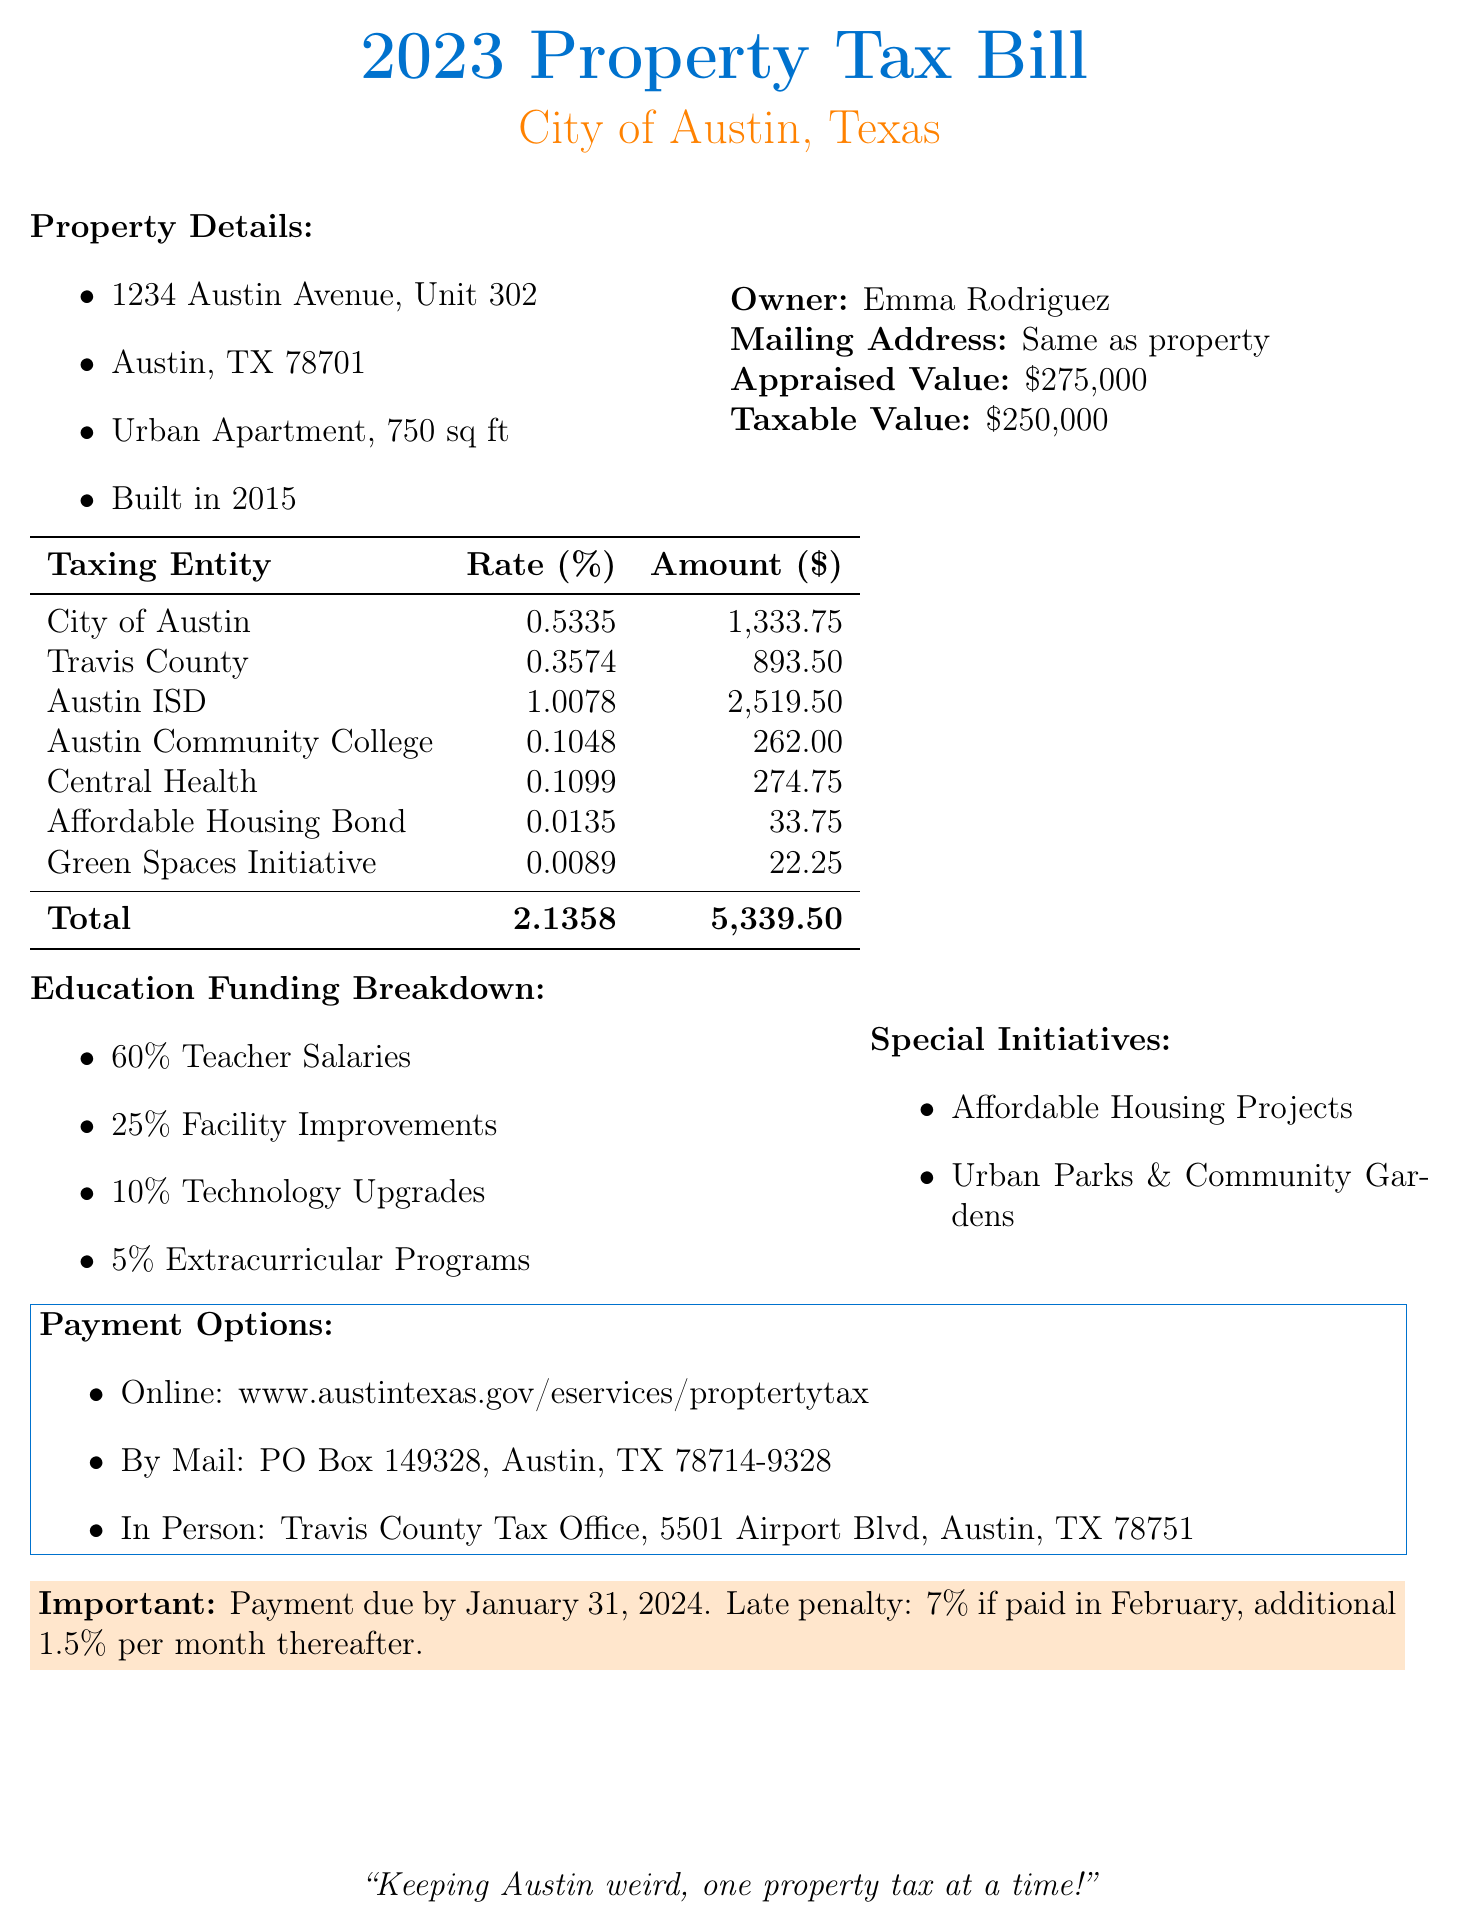What is the appraised value of the property? The appraised value of the property is stated in the document as $275,000.
Answer: $275,000 What is the total amount due for the property tax? The total amount due is found by looking at the Taxing Entity table's last row, showing the total amount as $5,339.50.
Answer: $5,339.50 How much of the education funding is allocated for teacher salaries? 60% of the education funding is specifically designated for teacher salaries, as indicated in the breakdown.
Answer: 60% What initiative is funded for affordable housing? The document mentions an Affordable Housing Bond as a taxing entity that supports affordable housing initiatives.
Answer: Affordable Housing Bond When is the payment due? The important due date for payment is highlighted in the document, stating it is due by January 31, 2024.
Answer: January 31, 2024 What percentage of the education funding is used for technology upgrades? The funding breakdown clearly indicates that 10% is allocated for technology upgrades.
Answer: 10% What is one of the special initiatives listed in the document? The document lists "Urban Parks & Community Gardens" as a special initiative for community improvement.
Answer: Urban Parks & Community Gardens Which taxing entity has the highest rate? The highest rate in the table is identified as Austin ISD, with a rate of 1.0078%.
Answer: Austin ISD What is the late penalty for February payments? The document specifies that the late penalty for February payments is 7%.
Answer: 7% 